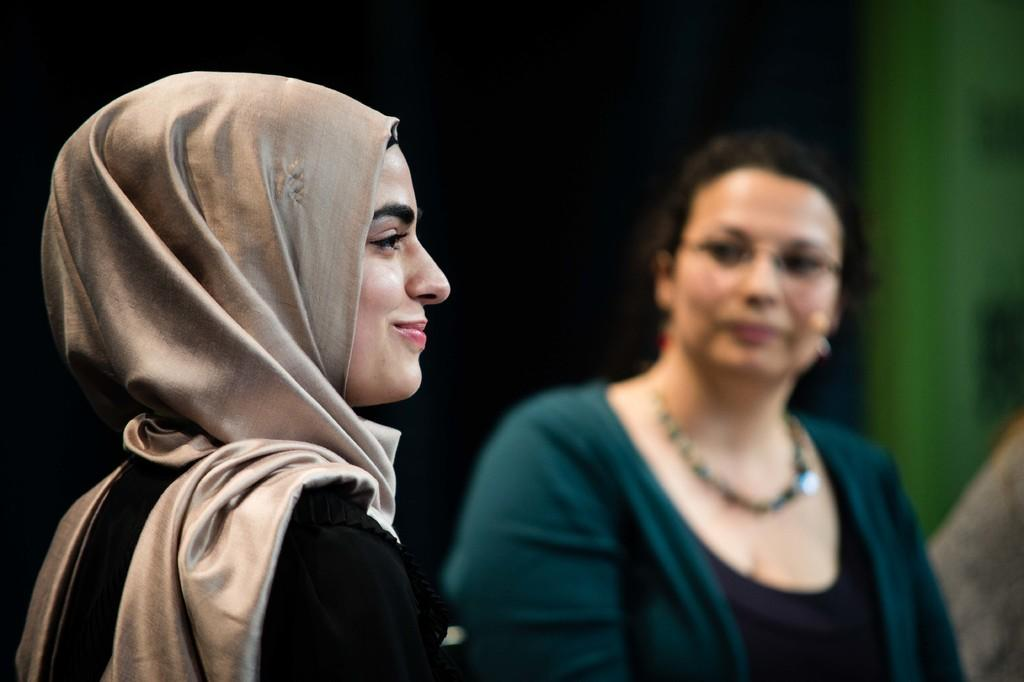How many women are in the image? There are two women in the image. What is the facial expression of the woman on the left side? The woman on the left side of the image is smiling. Which direction is the woman on the left side looking? The woman on the left side is looking towards the right side. How would you describe the background of the image? The background of the image has a dark view. What type of coach can be seen in the image? There is no coach present in the image. Can you describe the taste of the goose in the image? There is no goose present in the image, so it is not possible to describe its taste. 